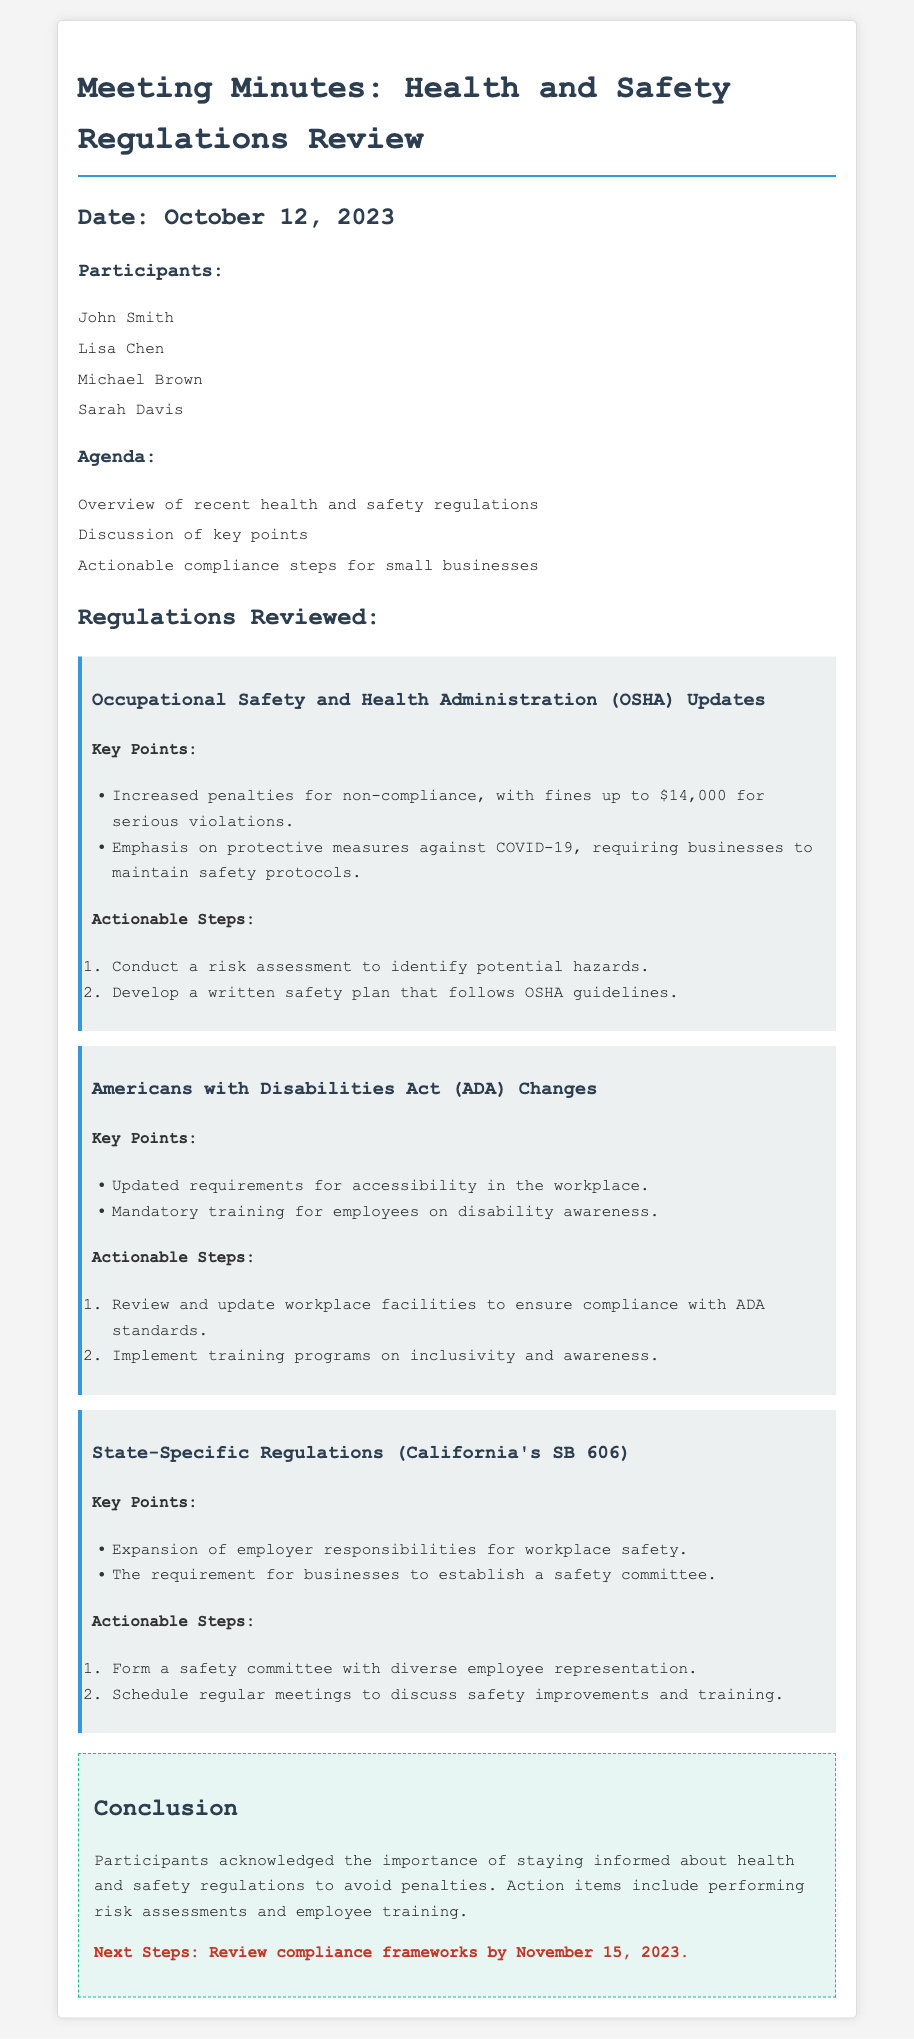What is the date of the meeting? The date of the meeting is mentioned at the beginning of the document.
Answer: October 12, 2023 Who are the participants in the meeting? The names of the participants are listed under the participants' section.
Answer: John Smith, Lisa Chen, Michael Brown, Sarah Davis What regulation was updated regarding COVID-19? The document specifies updates concerning safety protocols related to COVID-19 under the OSHA regulations.
Answer: OSHA Updates What is the fine amount for serious violations? The fine amount is stated within the key points of the OSHA updates section.
Answer: $14,000 What training is mandatory for employees under the ADA changes? The specific training requirement for employees is mentioned in the ADA changes section.
Answer: Disability awareness How often should the safety committee meet according to state-specific regulations? The document implies the need for regular meetings without a specific frequency mentioned.
Answer: Regularly What is the next step after reviewing compliance frameworks? The conclusion of the document suggests a follow-up action required by a specific date.
Answer: By November 15, 2023 What must businesses form according to California's SB 606? The requirement for businesses is explicitly stated in the key points of the state-specific regulations.
Answer: A safety committee What was the purpose of the meeting? The agenda outlines the main objectives of the meeting focused on regulations and compliance steps.
Answer: Review of recent health and safety regulations 